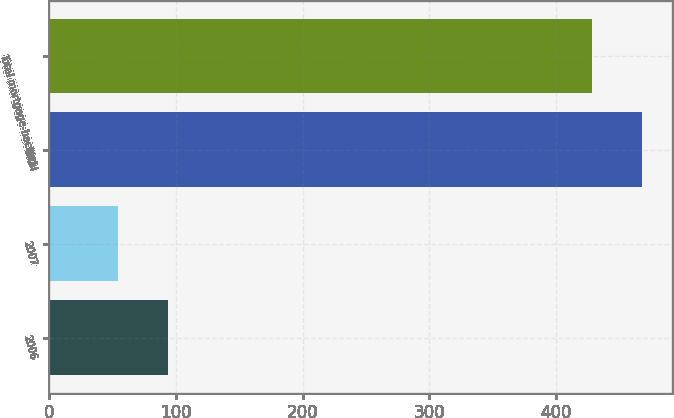<chart> <loc_0><loc_0><loc_500><loc_500><bar_chart><fcel>2006<fcel>2007<fcel>Total<fcel>Total mortgage-backed<nl><fcel>94<fcel>54<fcel>468<fcel>428<nl></chart> 